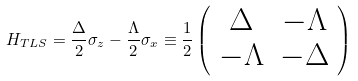<formula> <loc_0><loc_0><loc_500><loc_500>H _ { T L S } = \frac { \Delta } { 2 } \sigma _ { z } - \frac { \Lambda } { 2 } \sigma _ { x } \equiv \frac { 1 } { 2 } \left ( \begin{array} { c c } \Delta & - \Lambda \\ - \Lambda & - \Delta \end{array} \right )</formula> 